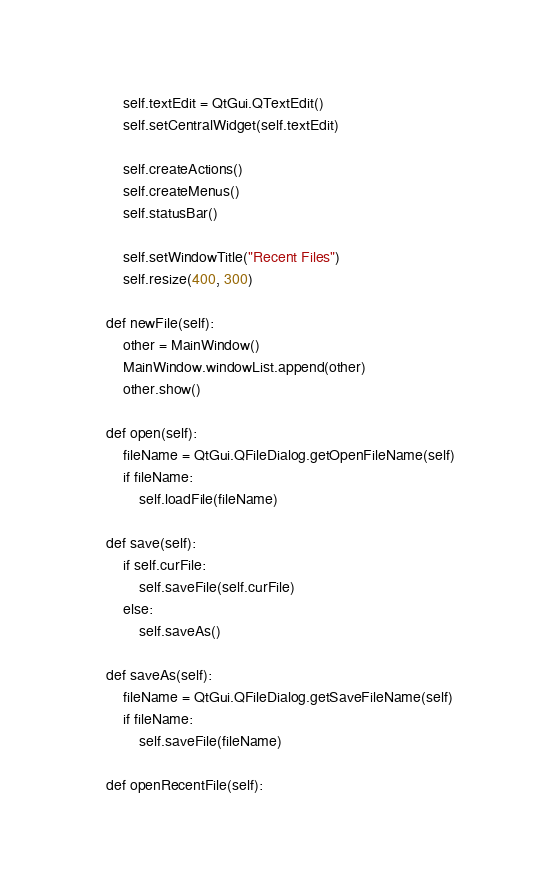<code> <loc_0><loc_0><loc_500><loc_500><_Python_>        self.textEdit = QtGui.QTextEdit()
        self.setCentralWidget(self.textEdit)

        self.createActions()
        self.createMenus()
        self.statusBar()

        self.setWindowTitle("Recent Files")
        self.resize(400, 300)

    def newFile(self):
        other = MainWindow()
        MainWindow.windowList.append(other)
        other.show()

    def open(self):
        fileName = QtGui.QFileDialog.getOpenFileName(self)
        if fileName:
            self.loadFile(fileName)
        	
    def save(self):
        if self.curFile:
            self.saveFile(self.curFile)
        else:
            self.saveAs()

    def saveAs(self):
        fileName = QtGui.QFileDialog.getSaveFileName(self)
        if fileName:
            self.saveFile(fileName)

    def openRecentFile(self):</code> 